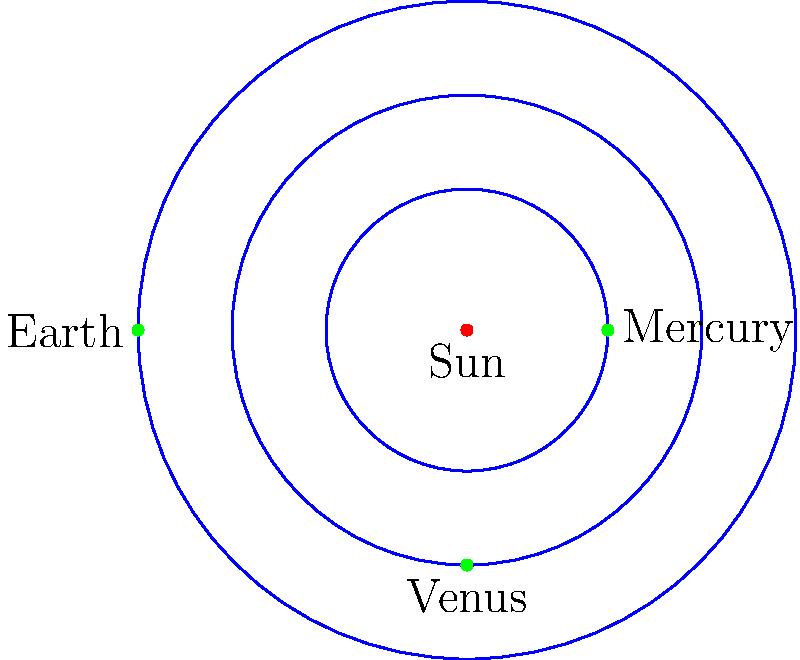In this simplified 2D representation of planetary orbits, which planet's orbit is most similar in size to the circular shape of a recorder's windway? Let's approach this step-by-step:

1. In the diagram, we see three planets orbiting the Sun: Mercury, Venus, and Earth.

2. Their orbits are represented as circular paths around the Sun, which is at the center.

3. The orbits are shown in increasing size from the Sun outward:
   - Mercury's orbit is the smallest
   - Venus's orbit is the middle-sized one
   - Earth's orbit is the largest

4. Now, let's consider the recorder's windway:
   - The windway of a recorder is a narrow channel through which the player blows air.
   - It's typically a small, circular or near-circular opening at the top of the instrument.

5. Comparing the relative sizes:
   - Mercury's orbit is the smallest and most closely resembles the size of a recorder's windway in relation to the overall image.
   - Venus's and Earth's orbits are significantly larger and less proportional to a recorder's windway.

6. While this is a simplified representation and not to scale, the concept of relative sizes is important in both astronomy and musical instrument design.

Therefore, Mercury's orbit is most similar in relative size to the circular shape of a recorder's windway.
Answer: Mercury 